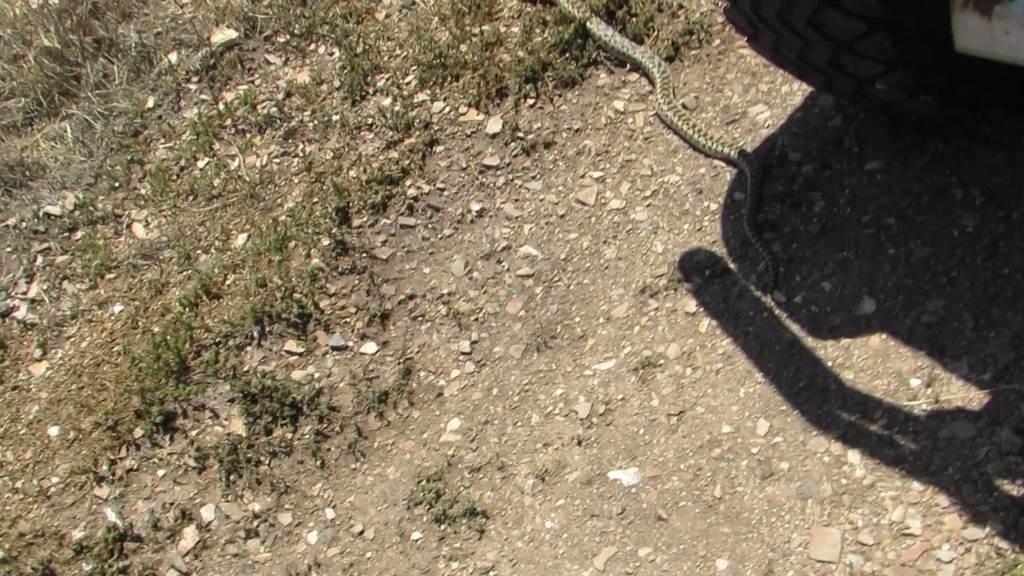Can you describe this image briefly? In this image we can see snake and tyre on the ground. 